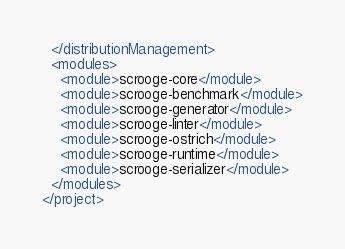<code> <loc_0><loc_0><loc_500><loc_500><_XML_>  </distributionManagement>
  <modules>
    <module>scrooge-core</module>
    <module>scrooge-benchmark</module>
    <module>scrooge-generator</module>
    <module>scrooge-linter</module>
    <module>scrooge-ostrich</module>
    <module>scrooge-runtime</module>
    <module>scrooge-serializer</module>
  </modules>
</project>
</code> 